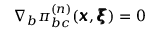Convert formula to latex. <formula><loc_0><loc_0><loc_500><loc_500>\nabla _ { b } \pi _ { b c } ^ { ( n ) } ( { \pm b x } , { \pm b \xi } ) = 0</formula> 